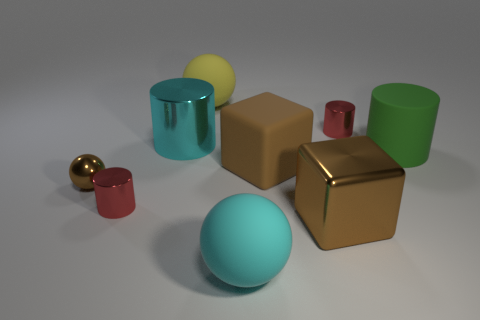Is the shape of the big cyan shiny object the same as the large object that is in front of the large shiny block?
Offer a very short reply. No. How many red cylinders have the same size as the cyan metallic cylinder?
Your answer should be very brief. 0. What is the material of the yellow thing that is the same shape as the cyan rubber object?
Offer a terse response. Rubber. There is a small cylinder that is on the right side of the brown matte object; does it have the same color as the tiny shiny cylinder that is in front of the metal ball?
Your response must be concise. Yes. The small red shiny object on the left side of the big yellow thing has what shape?
Offer a very short reply. Cylinder. The tiny shiny ball is what color?
Provide a succinct answer. Brown. There is a big yellow object that is made of the same material as the green cylinder; what is its shape?
Give a very brief answer. Sphere. There is a rubber sphere behind the green rubber object; is its size the same as the brown matte block?
Your answer should be very brief. Yes. What number of things are large cylinders that are behind the matte block or brown shiny things left of the cyan sphere?
Provide a short and direct response. 3. Do the block on the left side of the big brown shiny thing and the tiny metallic ball have the same color?
Offer a terse response. Yes. 